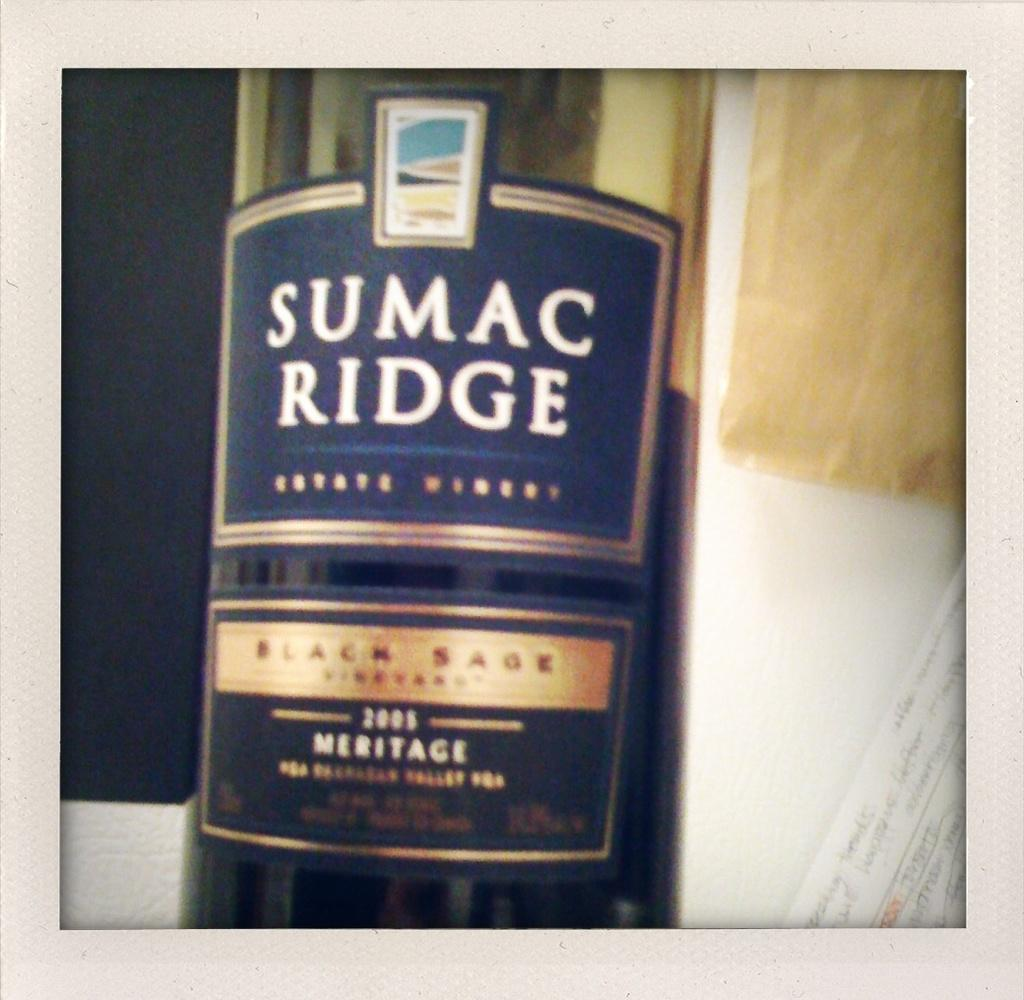<image>
Render a clear and concise summary of the photo. a sumac ridge bottle that has the year on it 